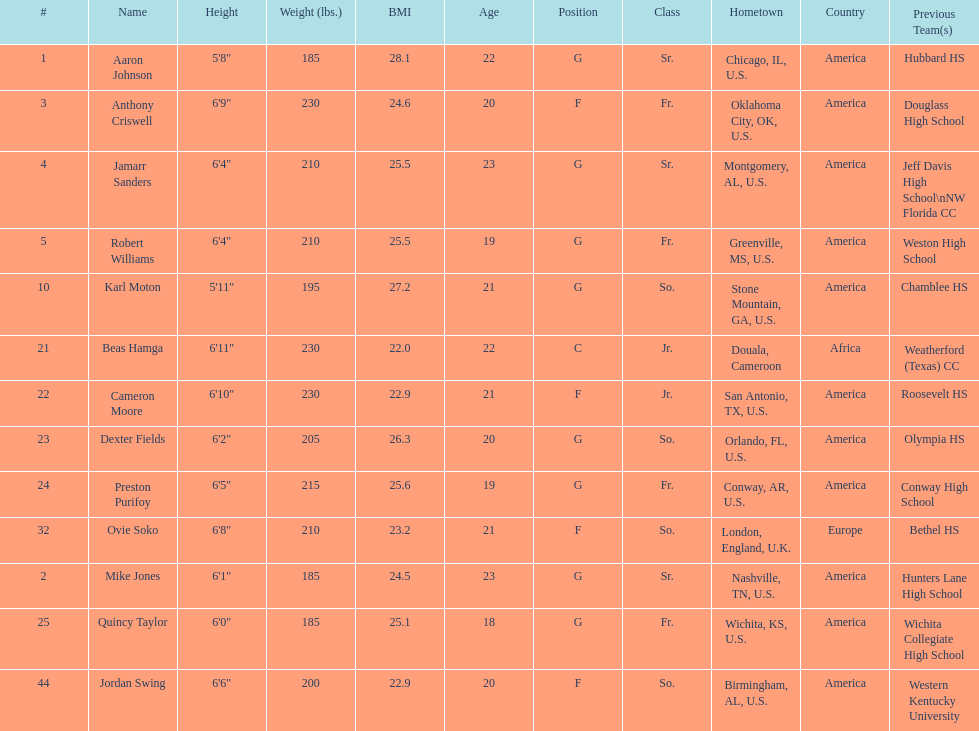Other than soko, tell me a player who is not from the us. Beas Hamga. 